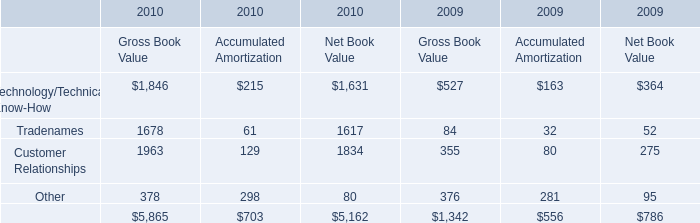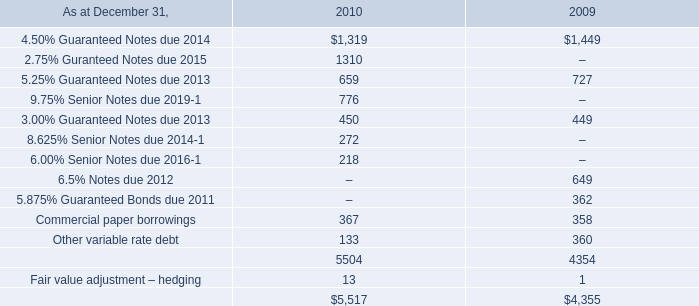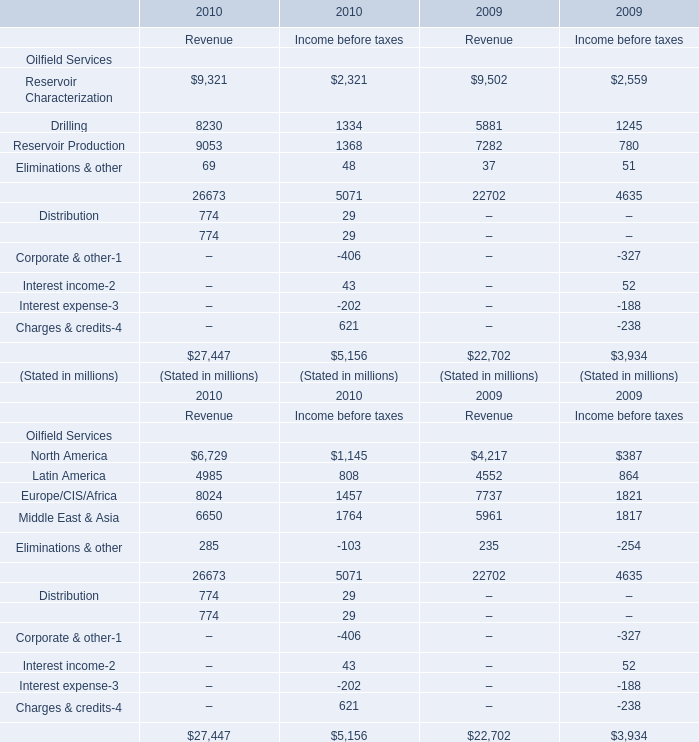What will Latin America for revenue reach in 2011 if it continues to grow at its current rate? (in million) 
Computations: ((((4985 - 4552) / 4552) + 1) * 4985)
Answer: 5459.18827. 